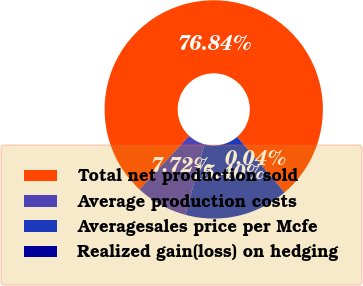Convert chart. <chart><loc_0><loc_0><loc_500><loc_500><pie_chart><fcel>Total net production sold<fcel>Average production costs<fcel>Averagesales price per Mcfe<fcel>Realized gain(loss) on hedging<nl><fcel>76.85%<fcel>7.72%<fcel>15.4%<fcel>0.04%<nl></chart> 